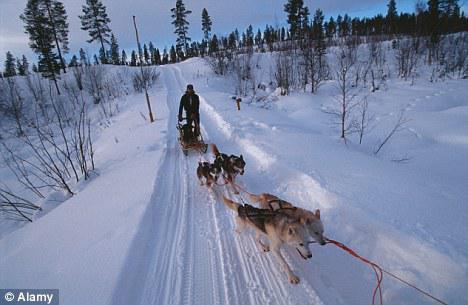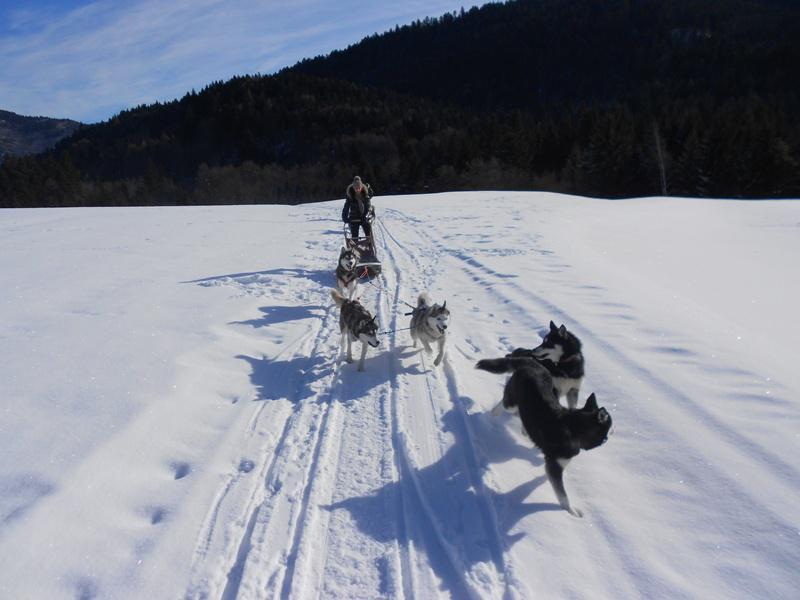The first image is the image on the left, the second image is the image on the right. For the images displayed, is the sentence "There are exactly three dogs pulling the sled in the image on the right" factually correct? Answer yes or no. No. The first image is the image on the left, the second image is the image on the right. Considering the images on both sides, is "The sled teams in the two images are headed in the same direction." valid? Answer yes or no. Yes. 